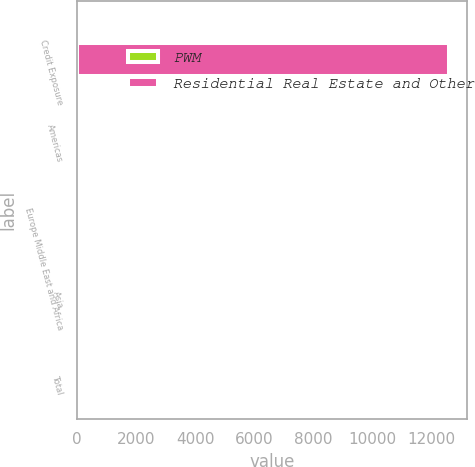Convert chart to OTSL. <chart><loc_0><loc_0><loc_500><loc_500><stacked_bar_chart><ecel><fcel>Credit Exposure<fcel>Americas<fcel>Europe Middle East and Africa<fcel>Asia<fcel>Total<nl><fcel>PWM<fcel>73<fcel>91<fcel>7<fcel>2<fcel>100<nl><fcel>Residential Real Estate and Other<fcel>12599<fcel>73<fcel>26<fcel>1<fcel>100<nl></chart> 